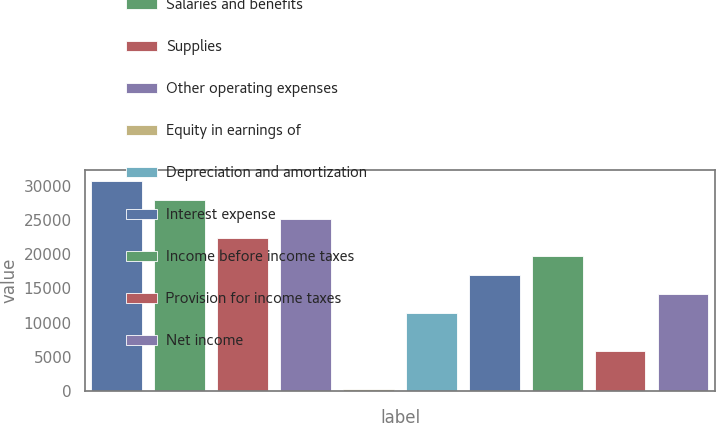Convert chart to OTSL. <chart><loc_0><loc_0><loc_500><loc_500><bar_chart><fcel>Revenues<fcel>Salaries and benefits<fcel>Supplies<fcel>Other operating expenses<fcel>Equity in earnings of<fcel>Depreciation and amortization<fcel>Interest expense<fcel>Income before income taxes<fcel>Provision for income taxes<fcel>Net income<nl><fcel>30810.3<fcel>28035<fcel>22484.4<fcel>25259.7<fcel>282<fcel>11383.2<fcel>16933.8<fcel>19709.1<fcel>5832.6<fcel>14158.5<nl></chart> 